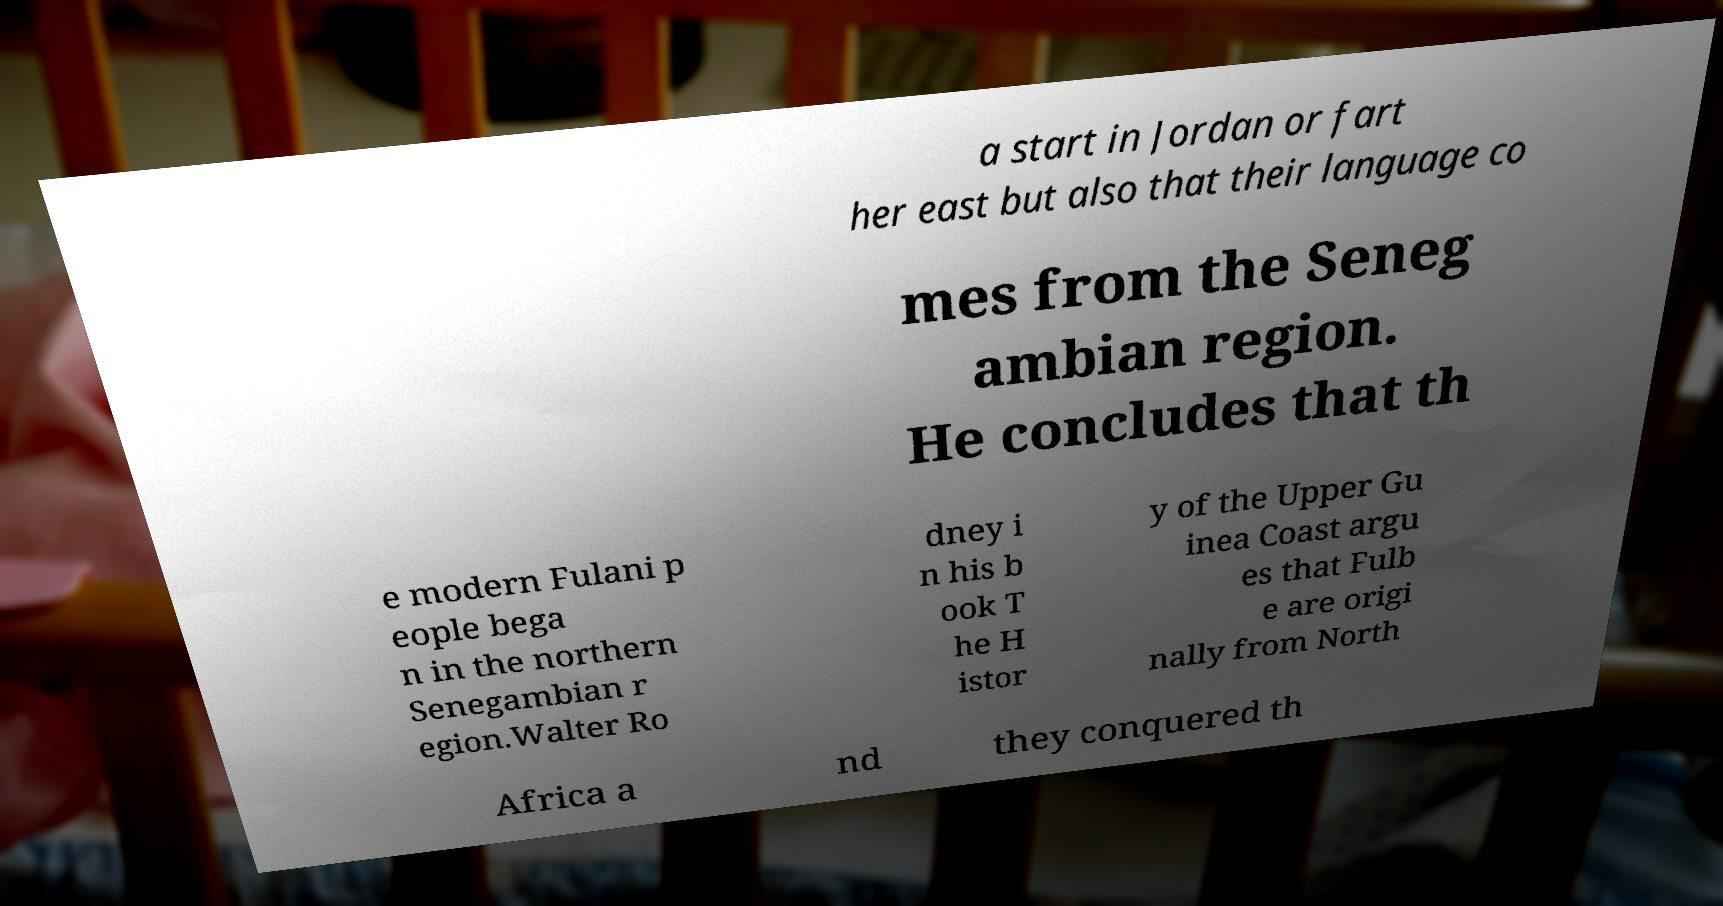Please identify and transcribe the text found in this image. a start in Jordan or fart her east but also that their language co mes from the Seneg ambian region. He concludes that th e modern Fulani p eople bega n in the northern Senegambian r egion.Walter Ro dney i n his b ook T he H istor y of the Upper Gu inea Coast argu es that Fulb e are origi nally from North Africa a nd they conquered th 